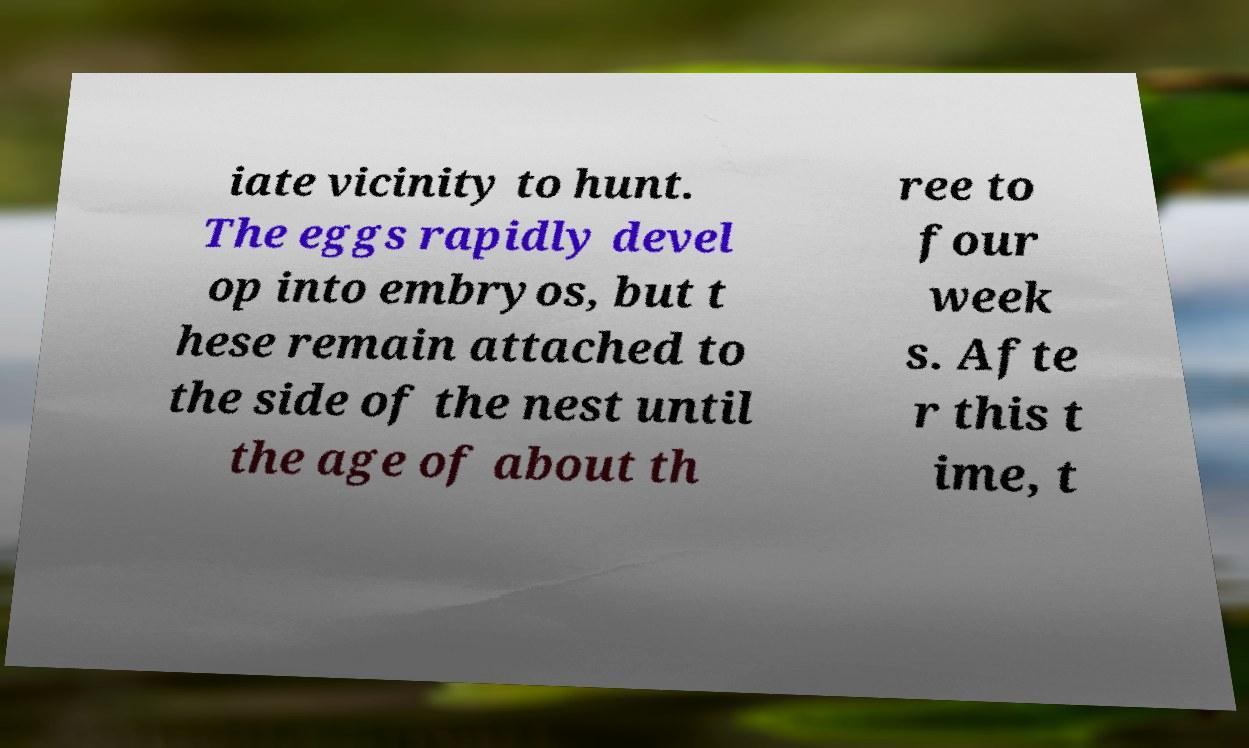Could you extract and type out the text from this image? iate vicinity to hunt. The eggs rapidly devel op into embryos, but t hese remain attached to the side of the nest until the age of about th ree to four week s. Afte r this t ime, t 